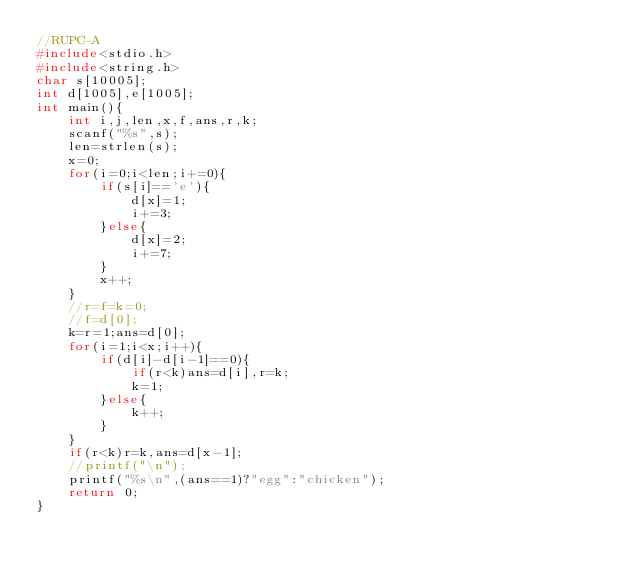<code> <loc_0><loc_0><loc_500><loc_500><_C_>//RUPC-A
#include<stdio.h>
#include<string.h>
char s[10005];
int d[1005],e[1005];
int main(){
	int i,j,len,x,f,ans,r,k;
	scanf("%s",s);
	len=strlen(s);
	x=0;
	for(i=0;i<len;i+=0){
		if(s[i]=='e'){
			d[x]=1;
			i+=3;
		}else{
			d[x]=2;
			i+=7;
		}
		x++;
	}
	//r=f=k=0;
	//f=d[0];
	k=r=1;ans=d[0];
	for(i=1;i<x;i++){
		if(d[i]-d[i-1]==0){
			if(r<k)ans=d[i],r=k;
			k=1;
		}else{
			k++;
		}
	}
	if(r<k)r=k,ans=d[x-1];
	//printf("\n");
	printf("%s\n",(ans==1)?"egg":"chicken");
	return 0;
}</code> 